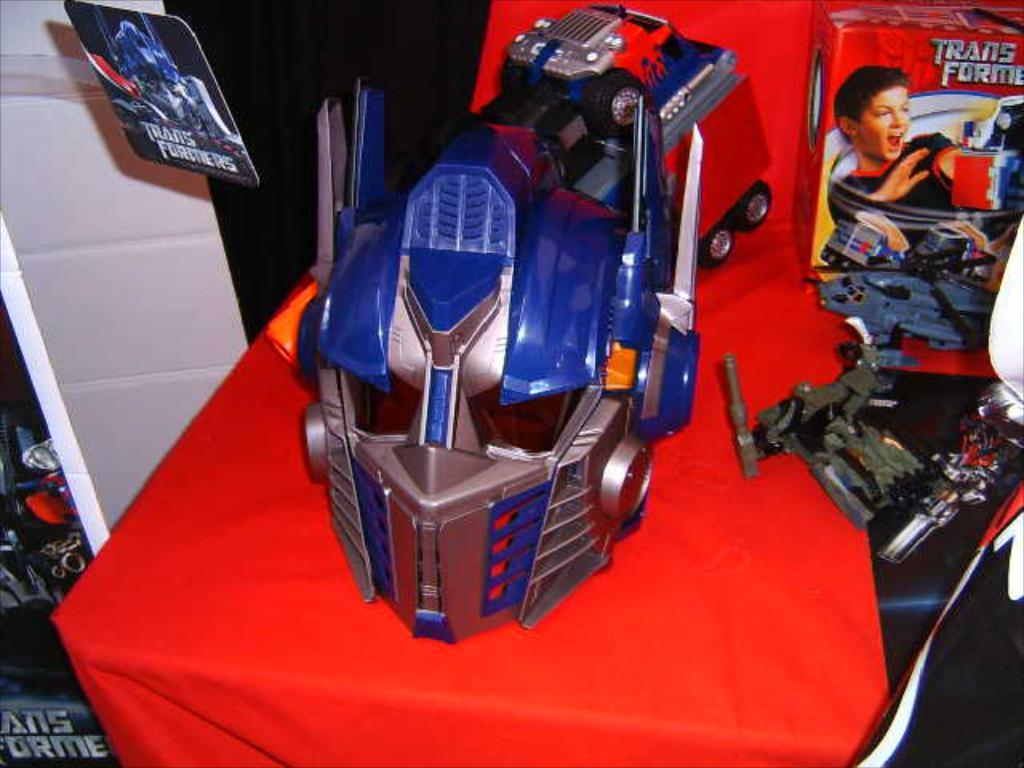<image>
Share a concise interpretation of the image provided. Helmet of a robot next to the word Transformer. 